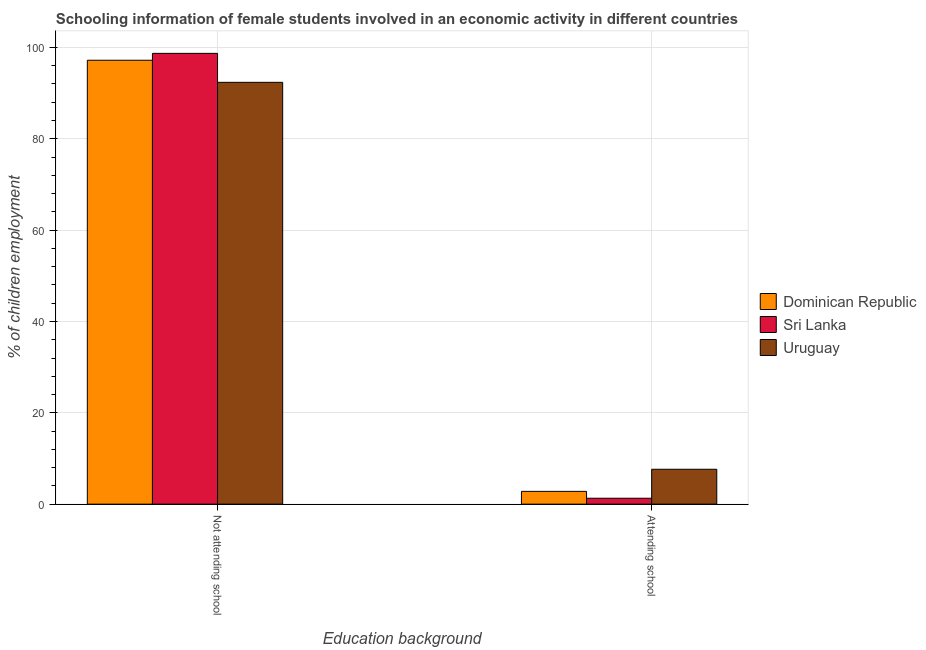How many different coloured bars are there?
Ensure brevity in your answer.  3. Are the number of bars per tick equal to the number of legend labels?
Your answer should be very brief. Yes. How many bars are there on the 2nd tick from the left?
Make the answer very short. 3. How many bars are there on the 1st tick from the right?
Provide a succinct answer. 3. What is the label of the 2nd group of bars from the left?
Offer a very short reply. Attending school. Across all countries, what is the maximum percentage of employed females who are attending school?
Your response must be concise. 7.64. Across all countries, what is the minimum percentage of employed females who are not attending school?
Offer a very short reply. 92.36. In which country was the percentage of employed females who are attending school maximum?
Give a very brief answer. Uruguay. In which country was the percentage of employed females who are attending school minimum?
Your answer should be very brief. Sri Lanka. What is the total percentage of employed females who are attending school in the graph?
Provide a succinct answer. 11.74. What is the difference between the percentage of employed females who are not attending school in Uruguay and that in Sri Lanka?
Keep it short and to the point. -6.35. What is the difference between the percentage of employed females who are attending school in Sri Lanka and the percentage of employed females who are not attending school in Dominican Republic?
Your response must be concise. -95.91. What is the average percentage of employed females who are attending school per country?
Your answer should be compact. 3.91. What is the difference between the percentage of employed females who are not attending school and percentage of employed females who are attending school in Sri Lanka?
Your answer should be very brief. 97.41. What is the ratio of the percentage of employed females who are attending school in Dominican Republic to that in Uruguay?
Offer a terse response. 0.37. What does the 3rd bar from the left in Not attending school represents?
Make the answer very short. Uruguay. What does the 1st bar from the right in Not attending school represents?
Your answer should be very brief. Uruguay. Are all the bars in the graph horizontal?
Provide a short and direct response. No. How many countries are there in the graph?
Your answer should be compact. 3. Does the graph contain any zero values?
Offer a terse response. No. Does the graph contain grids?
Your answer should be very brief. Yes. How many legend labels are there?
Provide a succinct answer. 3. How are the legend labels stacked?
Make the answer very short. Vertical. What is the title of the graph?
Your answer should be compact. Schooling information of female students involved in an economic activity in different countries. What is the label or title of the X-axis?
Provide a short and direct response. Education background. What is the label or title of the Y-axis?
Make the answer very short. % of children employment. What is the % of children employment in Dominican Republic in Not attending school?
Offer a terse response. 97.2. What is the % of children employment in Sri Lanka in Not attending school?
Offer a terse response. 98.71. What is the % of children employment of Uruguay in Not attending school?
Give a very brief answer. 92.36. What is the % of children employment in Dominican Republic in Attending school?
Give a very brief answer. 2.8. What is the % of children employment of Sri Lanka in Attending school?
Keep it short and to the point. 1.29. What is the % of children employment in Uruguay in Attending school?
Provide a succinct answer. 7.64. Across all Education background, what is the maximum % of children employment in Dominican Republic?
Your answer should be very brief. 97.2. Across all Education background, what is the maximum % of children employment in Sri Lanka?
Keep it short and to the point. 98.71. Across all Education background, what is the maximum % of children employment in Uruguay?
Ensure brevity in your answer.  92.36. Across all Education background, what is the minimum % of children employment of Dominican Republic?
Make the answer very short. 2.8. Across all Education background, what is the minimum % of children employment in Sri Lanka?
Provide a succinct answer. 1.29. Across all Education background, what is the minimum % of children employment of Uruguay?
Offer a terse response. 7.64. What is the total % of children employment in Dominican Republic in the graph?
Keep it short and to the point. 100. What is the difference between the % of children employment in Dominican Republic in Not attending school and that in Attending school?
Your response must be concise. 94.4. What is the difference between the % of children employment in Sri Lanka in Not attending school and that in Attending school?
Provide a short and direct response. 97.41. What is the difference between the % of children employment in Uruguay in Not attending school and that in Attending school?
Your answer should be very brief. 84.72. What is the difference between the % of children employment of Dominican Republic in Not attending school and the % of children employment of Sri Lanka in Attending school?
Give a very brief answer. 95.91. What is the difference between the % of children employment of Dominican Republic in Not attending school and the % of children employment of Uruguay in Attending school?
Offer a terse response. 89.56. What is the difference between the % of children employment in Sri Lanka in Not attending school and the % of children employment in Uruguay in Attending school?
Ensure brevity in your answer.  91.06. What is the average % of children employment in Sri Lanka per Education background?
Give a very brief answer. 50. What is the difference between the % of children employment in Dominican Republic and % of children employment in Sri Lanka in Not attending school?
Offer a terse response. -1.5. What is the difference between the % of children employment of Dominican Republic and % of children employment of Uruguay in Not attending school?
Provide a short and direct response. 4.84. What is the difference between the % of children employment in Sri Lanka and % of children employment in Uruguay in Not attending school?
Offer a very short reply. 6.35. What is the difference between the % of children employment in Dominican Republic and % of children employment in Sri Lanka in Attending school?
Provide a short and direct response. 1.5. What is the difference between the % of children employment of Dominican Republic and % of children employment of Uruguay in Attending school?
Make the answer very short. -4.84. What is the difference between the % of children employment in Sri Lanka and % of children employment in Uruguay in Attending school?
Offer a terse response. -6.35. What is the ratio of the % of children employment in Dominican Republic in Not attending school to that in Attending school?
Provide a short and direct response. 34.71. What is the ratio of the % of children employment of Sri Lanka in Not attending school to that in Attending school?
Keep it short and to the point. 76.22. What is the ratio of the % of children employment of Uruguay in Not attending school to that in Attending school?
Provide a short and direct response. 12.09. What is the difference between the highest and the second highest % of children employment in Dominican Republic?
Provide a succinct answer. 94.4. What is the difference between the highest and the second highest % of children employment of Sri Lanka?
Keep it short and to the point. 97.41. What is the difference between the highest and the second highest % of children employment in Uruguay?
Your response must be concise. 84.72. What is the difference between the highest and the lowest % of children employment in Dominican Republic?
Your answer should be compact. 94.4. What is the difference between the highest and the lowest % of children employment in Sri Lanka?
Offer a very short reply. 97.41. What is the difference between the highest and the lowest % of children employment in Uruguay?
Ensure brevity in your answer.  84.72. 